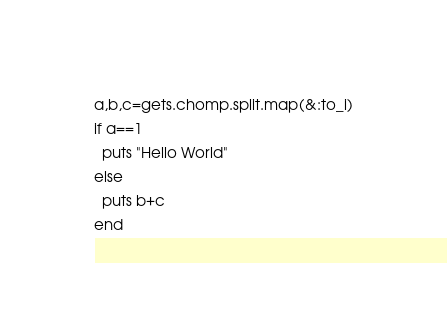<code> <loc_0><loc_0><loc_500><loc_500><_Ruby_>a,b,c=gets.chomp.split.map(&:to_i)
if a==1
  puts "Hello World"
else
  puts b+c
end</code> 